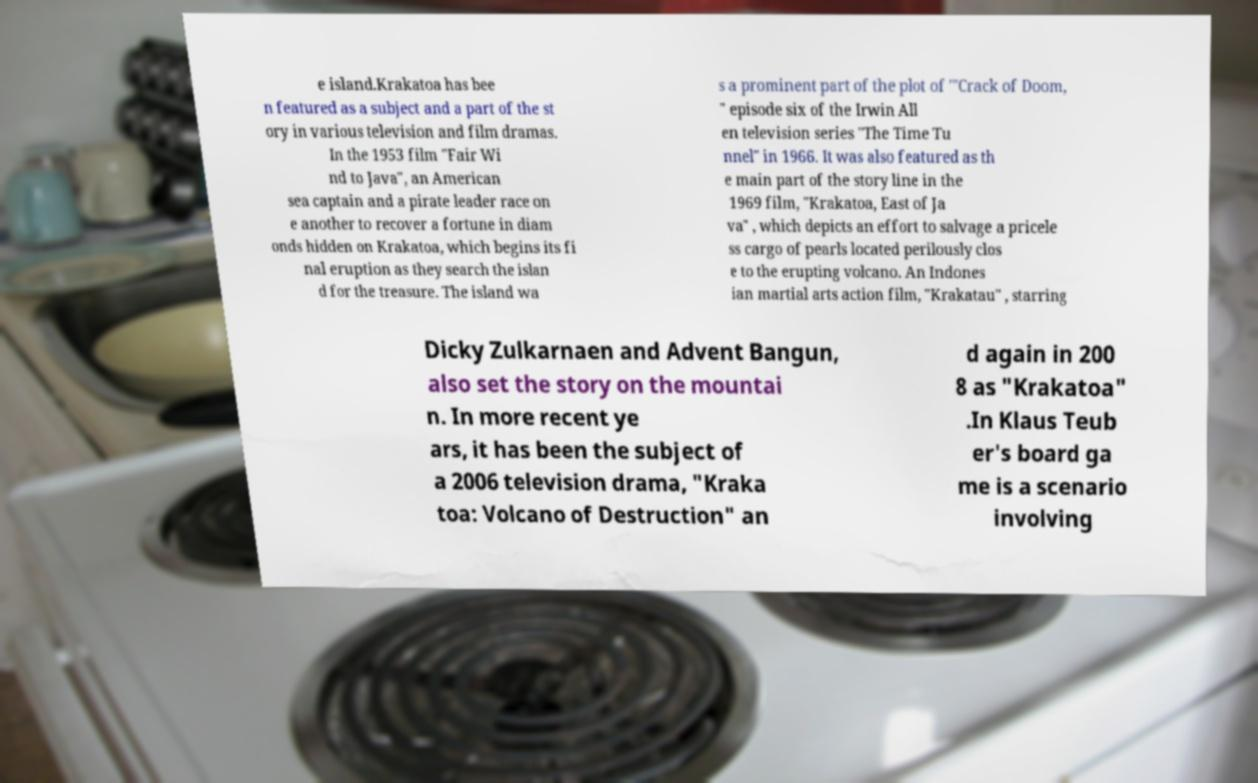Could you extract and type out the text from this image? e island.Krakatoa has bee n featured as a subject and a part of the st ory in various television and film dramas. In the 1953 film "Fair Wi nd to Java", an American sea captain and a pirate leader race on e another to recover a fortune in diam onds hidden on Krakatoa, which begins its fi nal eruption as they search the islan d for the treasure. The island wa s a prominent part of the plot of '"Crack of Doom, " episode six of the Irwin All en television series "The Time Tu nnel" in 1966. It was also featured as th e main part of the story line in the 1969 film, "Krakatoa, East of Ja va" , which depicts an effort to salvage a pricele ss cargo of pearls located perilously clos e to the erupting volcano. An Indones ian martial arts action film, "Krakatau" , starring Dicky Zulkarnaen and Advent Bangun, also set the story on the mountai n. In more recent ye ars, it has been the subject of a 2006 television drama, "Kraka toa: Volcano of Destruction" an d again in 200 8 as "Krakatoa" .In Klaus Teub er's board ga me is a scenario involving 